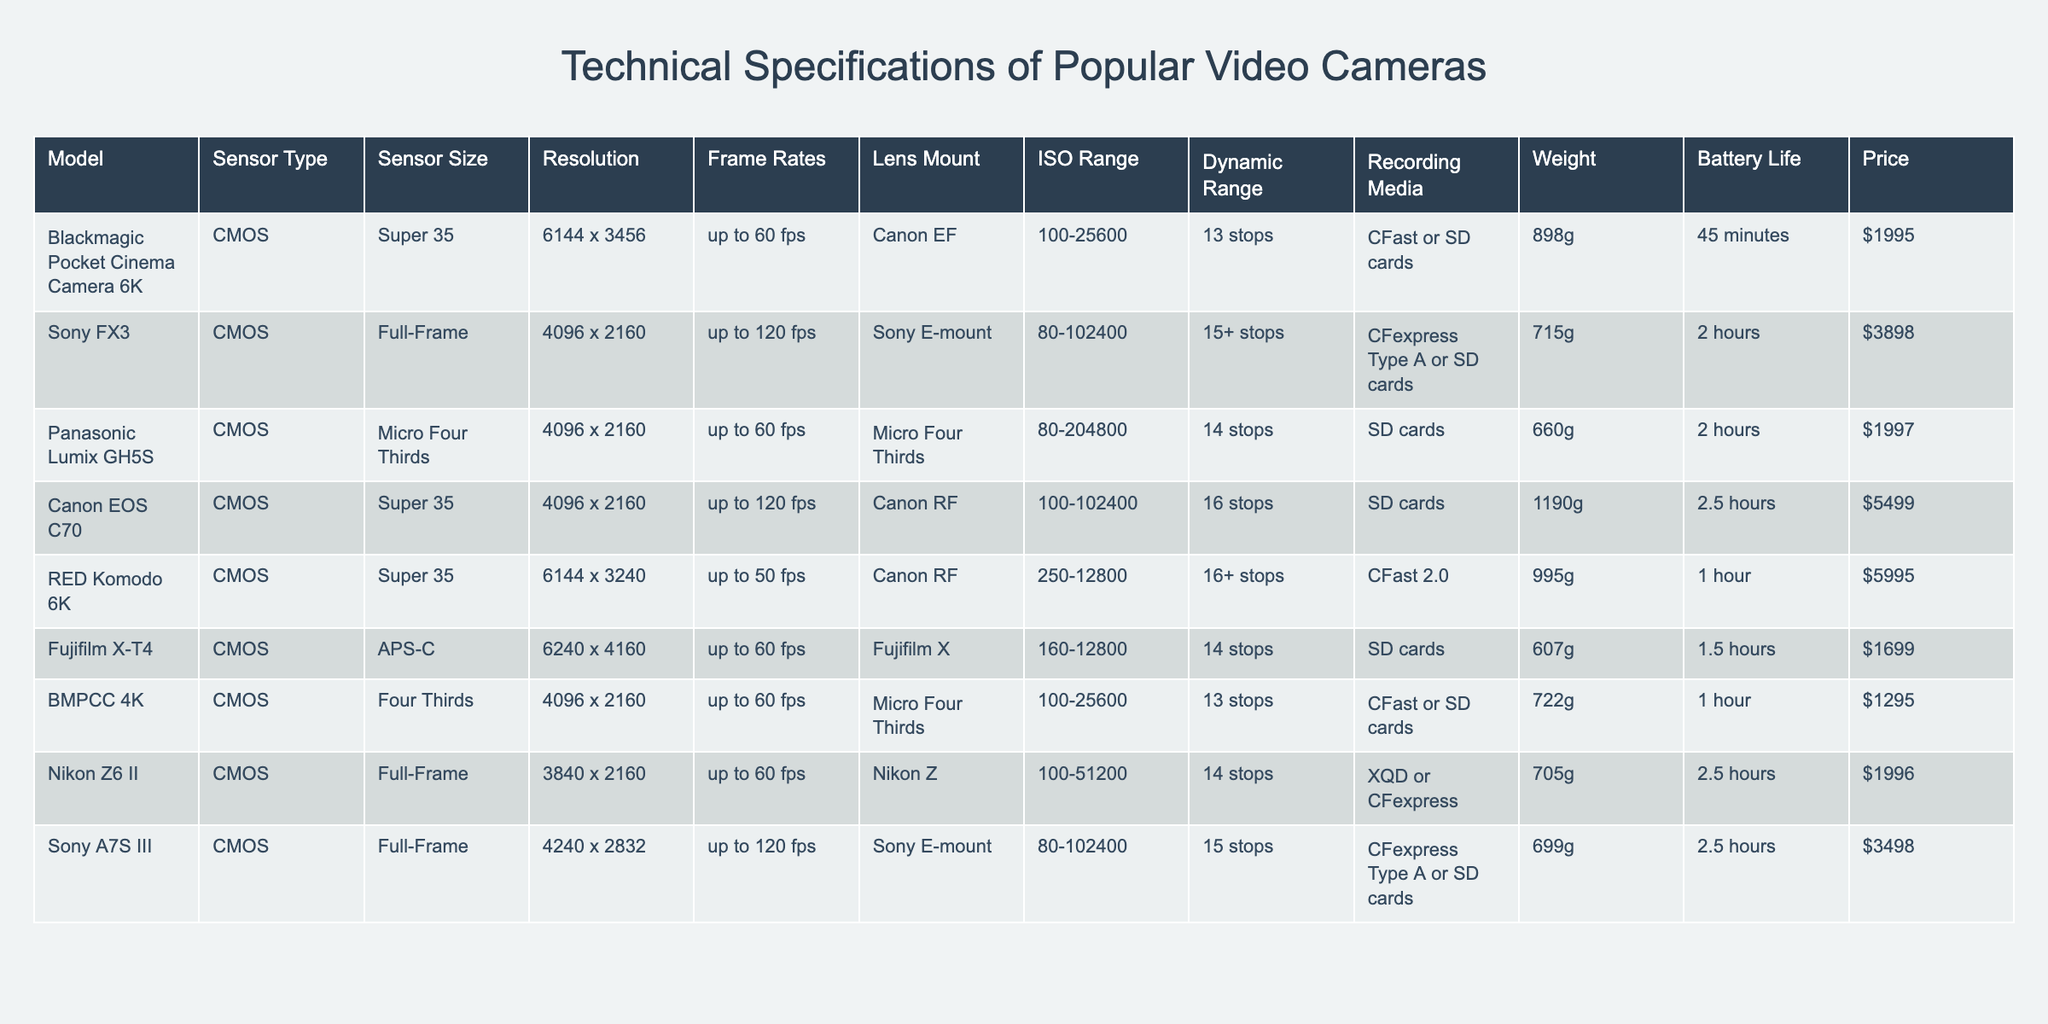What is the resolution of the Sony A7S III camera? Looking at the table, I find the row for the Sony A7S III, and I see that its resolution is listed as 4240 x 2832.
Answer: 4240 x 2832 Which camera has the highest dynamic range? From the table, I can compare the dynamic ranges listed. The Canon EOS C70 and RED Komodo 6K both have a dynamic range of 16 stops which is the highest in the list.
Answer: Canon EOS C70 and RED Komodo 6K How much does the Blackmagic Pocket Cinema Camera 6K weigh? Referring to the entry for the Blackmagic Pocket Cinema Camera 6K, I see it has a weight of 898 grams.
Answer: 898 grams What is the average battery life of all cameras listed? I compute the battery life for all cameras: 45 minutes, 120 minutes, 120 minutes, 150 minutes, 60 minutes, 90 minutes, 60 minutes, 150 minutes. Summing them gives 735 minutes and dividing by 8 (the number of cameras) results in an average of approximately 91.88 minutes.
Answer: Approximately 91.88 minutes Is the Panasonic Lumix GH5S more expensive than the Fujifilm X-T4? I check the prices in the table: Panasonic Lumix GH5S is priced at $1997, while Fujifilm X-T4 is priced at $1699. Since $1997 is greater than $1699, the statement is true.
Answer: Yes What is the price difference between the Canon EOS C70 and the Sony FX3? I find the price of the Canon EOS C70 is $5499 and the price of the Sony FX3 is $3898. The difference in price is calculated as $5499 - $3898 = $1601.
Answer: $1601 Which camera has the longest battery life, and how long is it? Looking at the battery life values, the Canon EOS C70 has the longest battery life of 150 minutes.
Answer: Canon EOS C70, 150 minutes Are there any cameras in the list with an ISO range exceeding 100,000? By examining the ISO ranges, I notice that both the Sony FX3 (80-102400) and Canon EOS C70 (100-102400) can exceed 100,000 based on their maximum values. Therefore, the answer is yes.
Answer: Yes If I wanted the lightest camera, which one would I choose? I examine each camera's weight and find that the Fujifilm X-T4 is the lightest at 607 grams.
Answer: Fujifilm X-T4 How many cameras have a sensor size classified as "Full-Frame"? I count the entries with a sensor size of "Full-Frame" which includes three cameras: Sony FX3, Nikon Z6 II, and Sony A7S III. Therefore, there are three cameras.
Answer: 3 